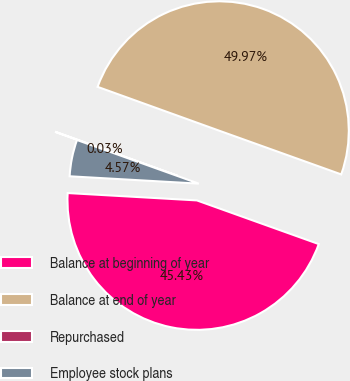<chart> <loc_0><loc_0><loc_500><loc_500><pie_chart><fcel>Balance at beginning of year<fcel>Balance at end of year<fcel>Repurchased<fcel>Employee stock plans<nl><fcel>45.43%<fcel>49.97%<fcel>0.03%<fcel>4.57%<nl></chart> 